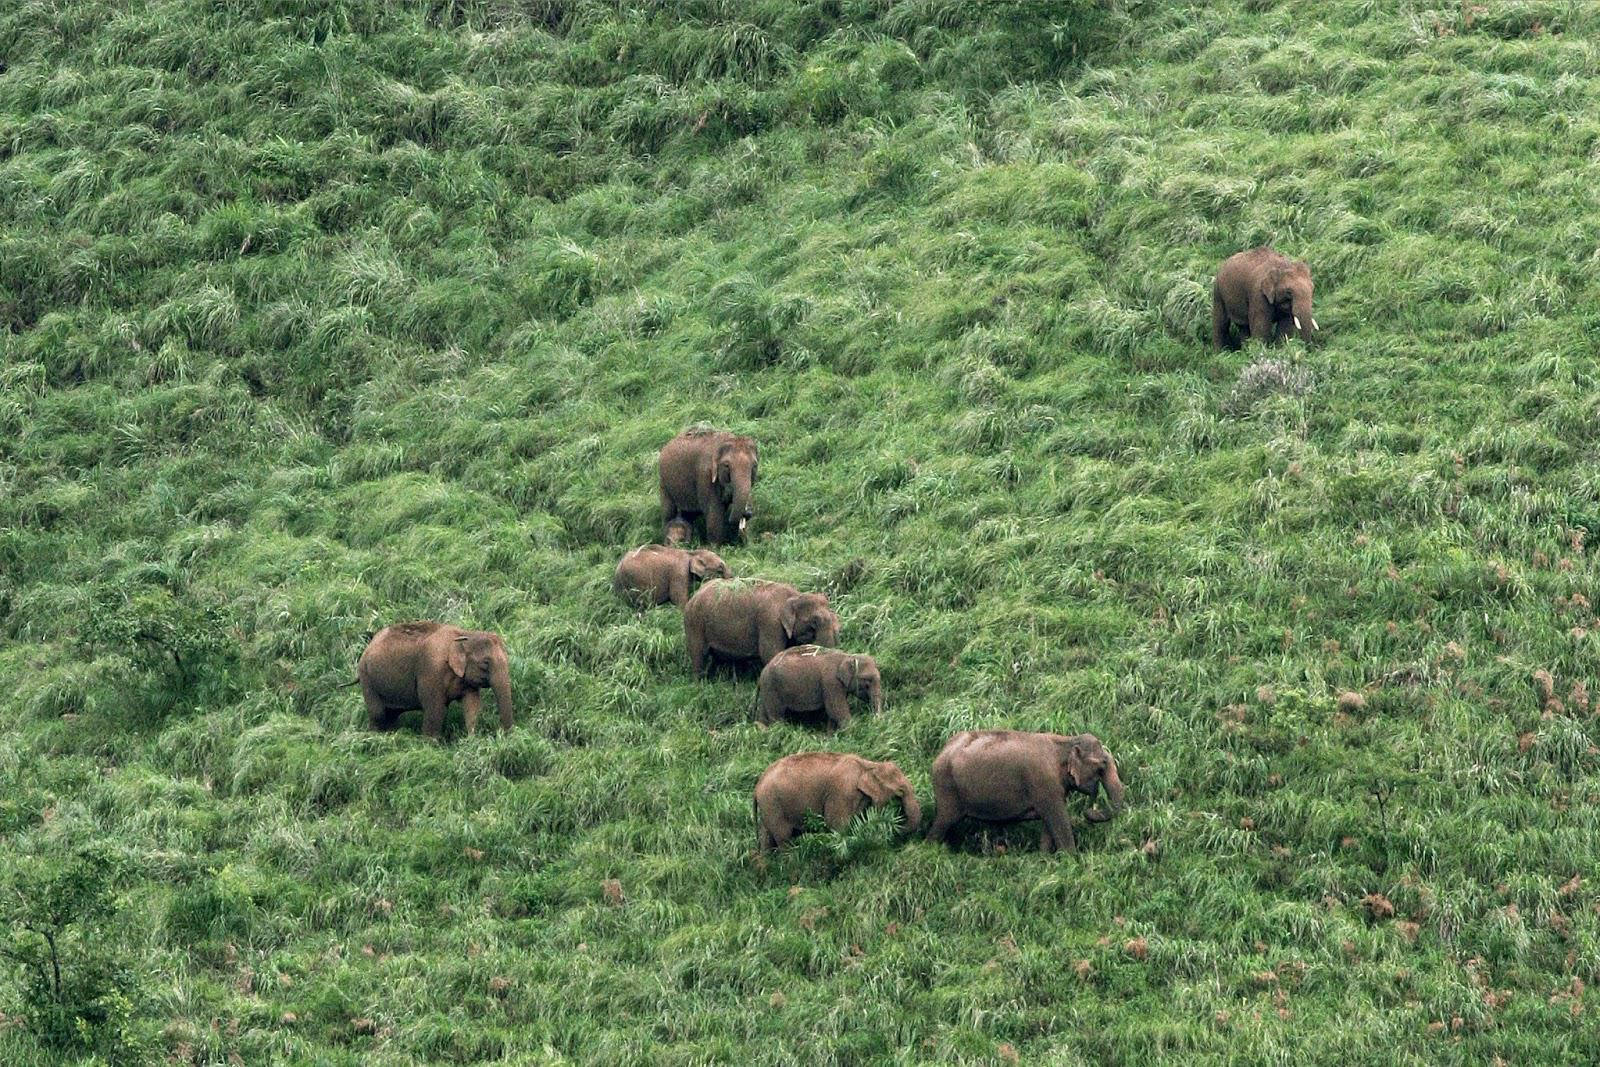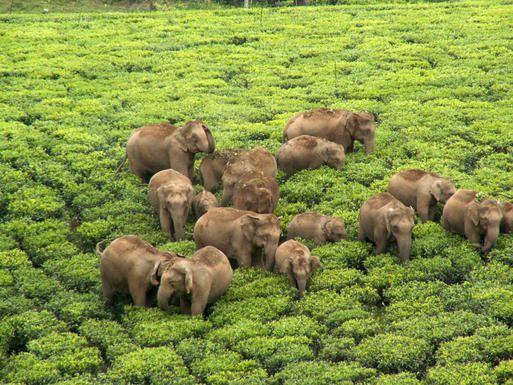The first image is the image on the left, the second image is the image on the right. Assess this claim about the two images: "Some of the animals are near the water.". Correct or not? Answer yes or no. No. 